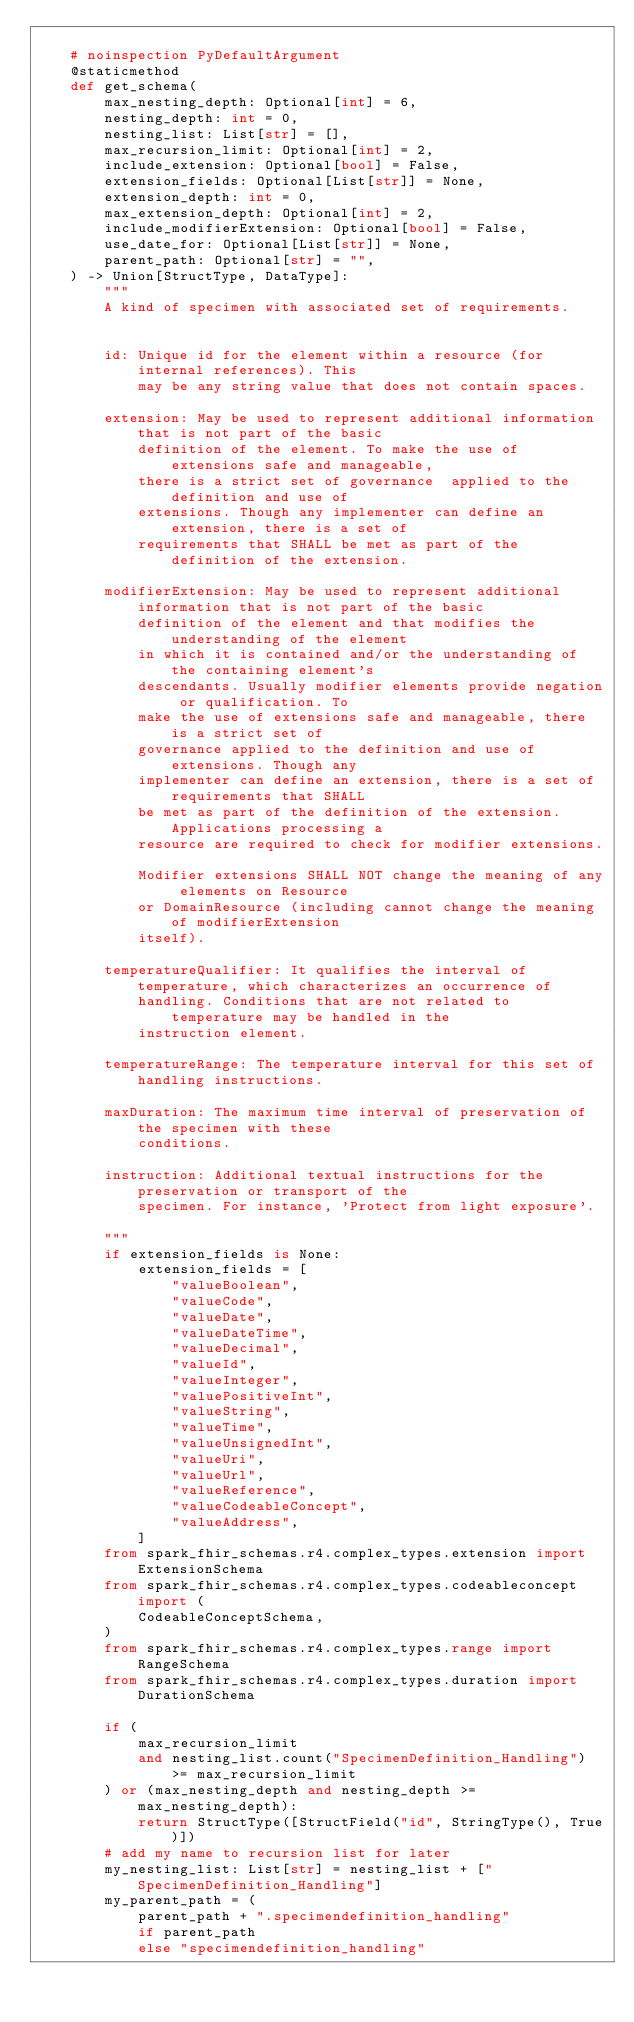<code> <loc_0><loc_0><loc_500><loc_500><_Python_>
    # noinspection PyDefaultArgument
    @staticmethod
    def get_schema(
        max_nesting_depth: Optional[int] = 6,
        nesting_depth: int = 0,
        nesting_list: List[str] = [],
        max_recursion_limit: Optional[int] = 2,
        include_extension: Optional[bool] = False,
        extension_fields: Optional[List[str]] = None,
        extension_depth: int = 0,
        max_extension_depth: Optional[int] = 2,
        include_modifierExtension: Optional[bool] = False,
        use_date_for: Optional[List[str]] = None,
        parent_path: Optional[str] = "",
    ) -> Union[StructType, DataType]:
        """
        A kind of specimen with associated set of requirements.


        id: Unique id for the element within a resource (for internal references). This
            may be any string value that does not contain spaces.

        extension: May be used to represent additional information that is not part of the basic
            definition of the element. To make the use of extensions safe and manageable,
            there is a strict set of governance  applied to the definition and use of
            extensions. Though any implementer can define an extension, there is a set of
            requirements that SHALL be met as part of the definition of the extension.

        modifierExtension: May be used to represent additional information that is not part of the basic
            definition of the element and that modifies the understanding of the element
            in which it is contained and/or the understanding of the containing element's
            descendants. Usually modifier elements provide negation or qualification. To
            make the use of extensions safe and manageable, there is a strict set of
            governance applied to the definition and use of extensions. Though any
            implementer can define an extension, there is a set of requirements that SHALL
            be met as part of the definition of the extension. Applications processing a
            resource are required to check for modifier extensions.

            Modifier extensions SHALL NOT change the meaning of any elements on Resource
            or DomainResource (including cannot change the meaning of modifierExtension
            itself).

        temperatureQualifier: It qualifies the interval of temperature, which characterizes an occurrence of
            handling. Conditions that are not related to temperature may be handled in the
            instruction element.

        temperatureRange: The temperature interval for this set of handling instructions.

        maxDuration: The maximum time interval of preservation of the specimen with these
            conditions.

        instruction: Additional textual instructions for the preservation or transport of the
            specimen. For instance, 'Protect from light exposure'.

        """
        if extension_fields is None:
            extension_fields = [
                "valueBoolean",
                "valueCode",
                "valueDate",
                "valueDateTime",
                "valueDecimal",
                "valueId",
                "valueInteger",
                "valuePositiveInt",
                "valueString",
                "valueTime",
                "valueUnsignedInt",
                "valueUri",
                "valueUrl",
                "valueReference",
                "valueCodeableConcept",
                "valueAddress",
            ]
        from spark_fhir_schemas.r4.complex_types.extension import ExtensionSchema
        from spark_fhir_schemas.r4.complex_types.codeableconcept import (
            CodeableConceptSchema,
        )
        from spark_fhir_schemas.r4.complex_types.range import RangeSchema
        from spark_fhir_schemas.r4.complex_types.duration import DurationSchema

        if (
            max_recursion_limit
            and nesting_list.count("SpecimenDefinition_Handling") >= max_recursion_limit
        ) or (max_nesting_depth and nesting_depth >= max_nesting_depth):
            return StructType([StructField("id", StringType(), True)])
        # add my name to recursion list for later
        my_nesting_list: List[str] = nesting_list + ["SpecimenDefinition_Handling"]
        my_parent_path = (
            parent_path + ".specimendefinition_handling"
            if parent_path
            else "specimendefinition_handling"</code> 